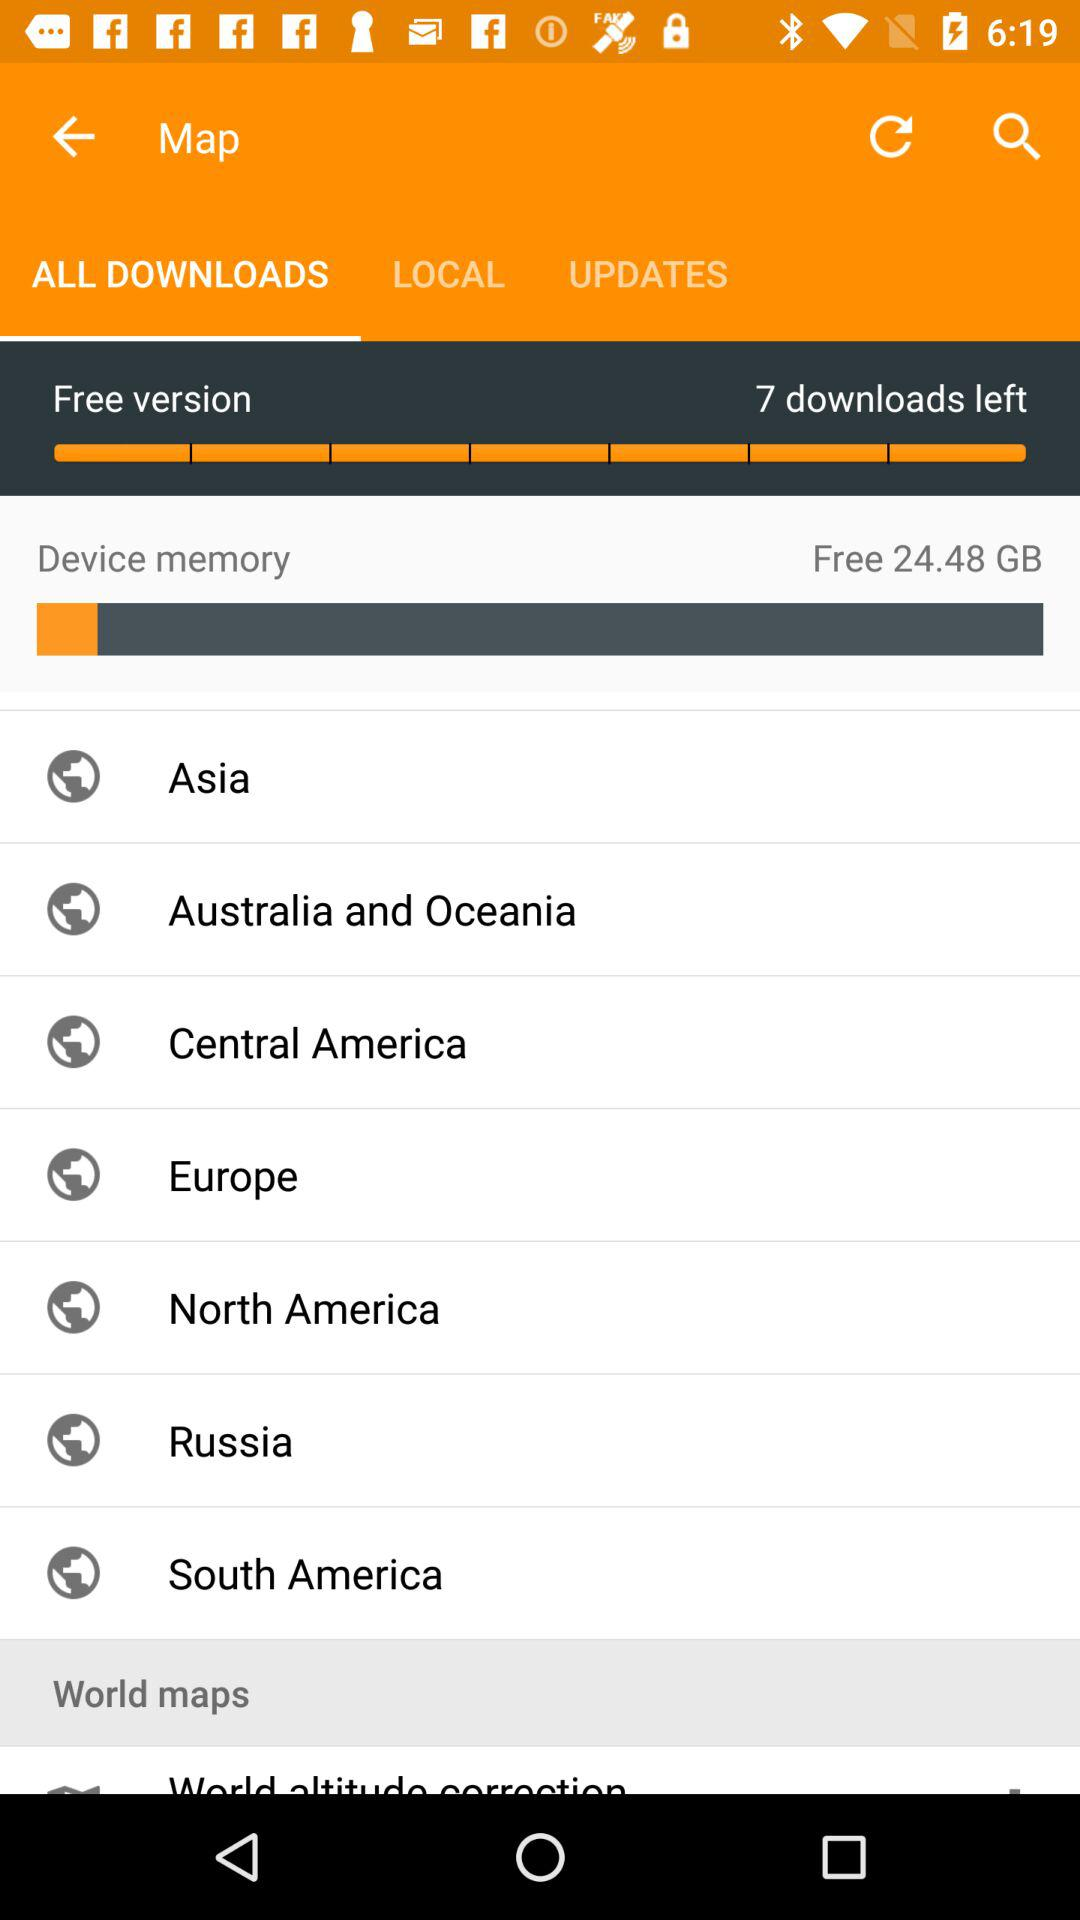Which tab is selected? The selected tab is "ALL DOWNLOADS". 